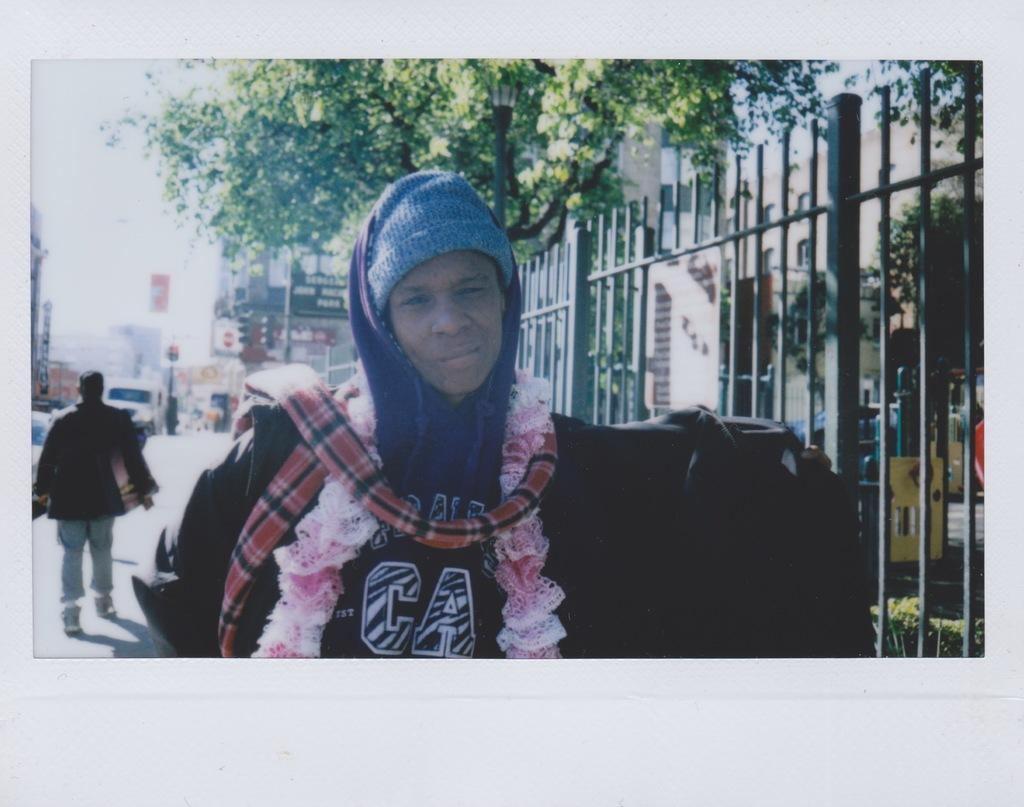<image>
Give a short and clear explanation of the subsequent image. A young person dressed in warm clothes and wearing a jacked that as the letters c and a on it. 